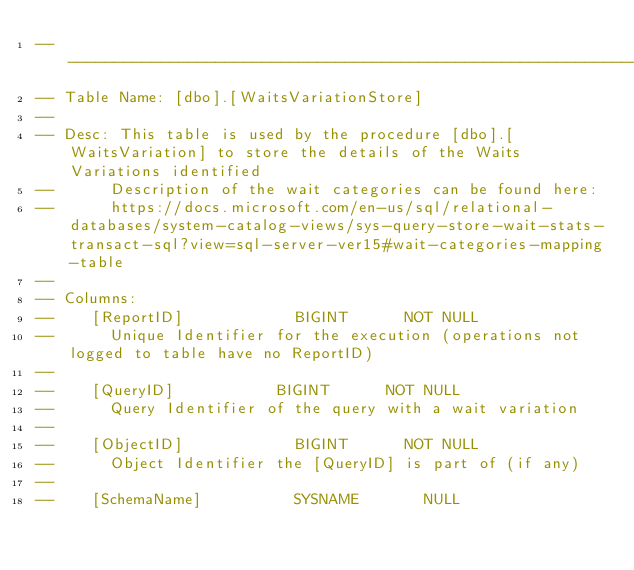Convert code to text. <code><loc_0><loc_0><loc_500><loc_500><_SQL_>----------------------------------------------------------------------------------
-- Table Name: [dbo].[WaitsVariationStore]
--
-- Desc: This table is used by the procedure [dbo].[WaitsVariation] to store the details of the Waits Variations identified
--			Description of the wait categories can be found here:
--			https://docs.microsoft.com/en-us/sql/relational-databases/system-catalog-views/sys-query-store-wait-stats-transact-sql?view=sql-server-ver15#wait-categories-mapping-table
--
-- Columns:
--		[ReportID]						BIGINT			NOT NULL
--			Unique Identifier for the execution (operations not logged to table have no ReportID)
--
--		[QueryID]						BIGINT			NOT NULL
--			Query Identifier of the query with a wait variation
--
--		[ObjectID]						BIGINT			NOT NULL
--			Object Identifier the [QueryID] is part of (if any)
--
--		[SchemaName]					SYSNAME				NULL</code> 